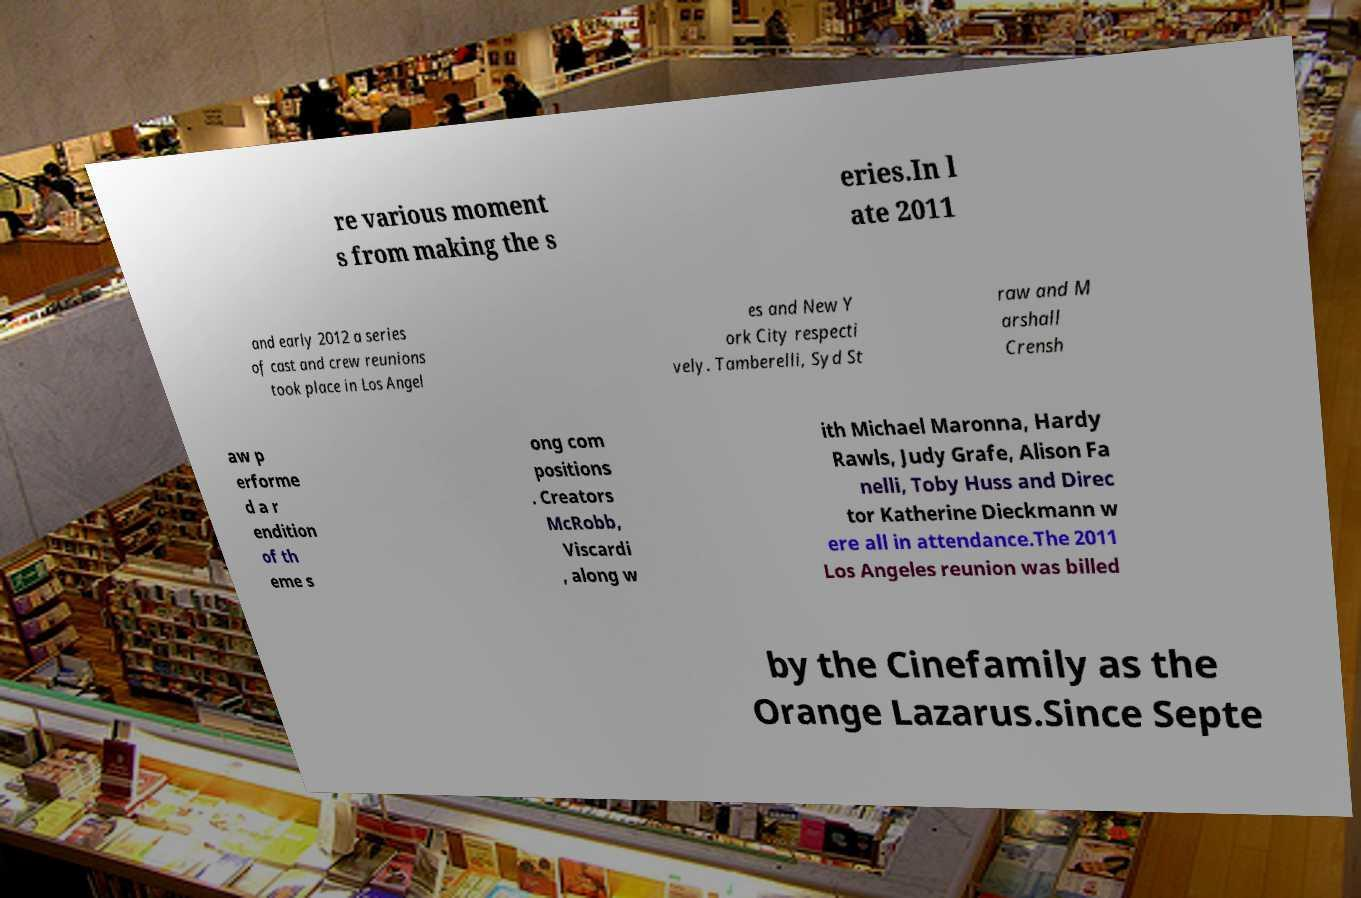Could you assist in decoding the text presented in this image and type it out clearly? re various moment s from making the s eries.In l ate 2011 and early 2012 a series of cast and crew reunions took place in Los Angel es and New Y ork City respecti vely. Tamberelli, Syd St raw and M arshall Crensh aw p erforme d a r endition of th eme s ong com positions . Creators McRobb, Viscardi , along w ith Michael Maronna, Hardy Rawls, Judy Grafe, Alison Fa nelli, Toby Huss and Direc tor Katherine Dieckmann w ere all in attendance.The 2011 Los Angeles reunion was billed by the Cinefamily as the Orange Lazarus.Since Septe 